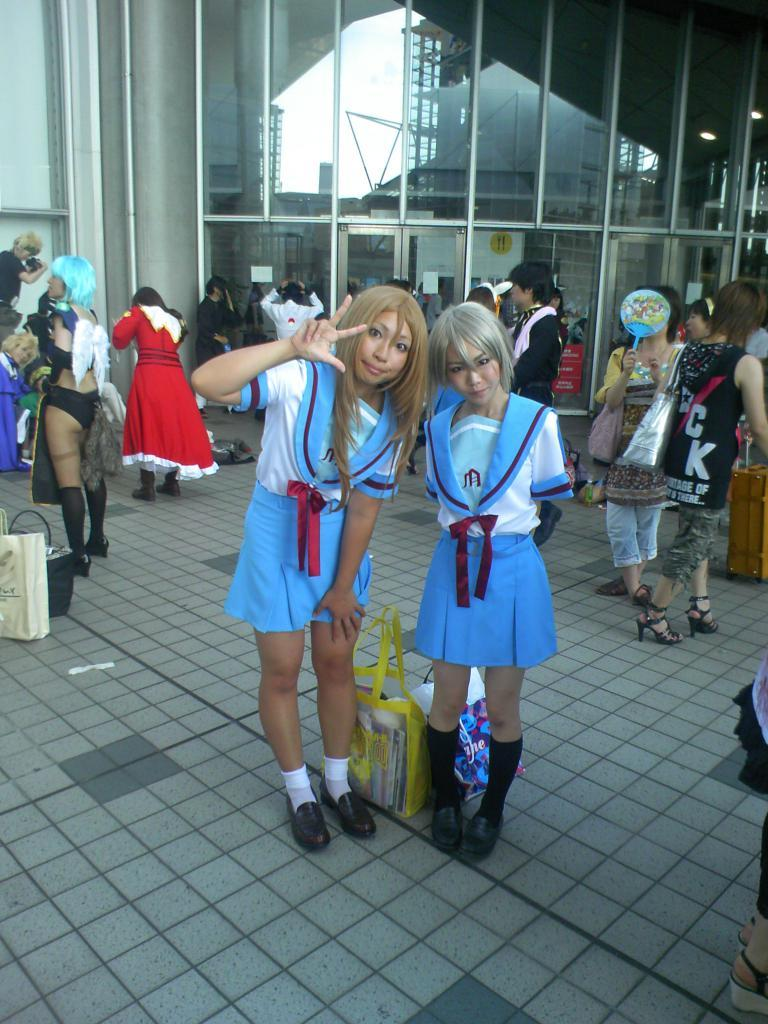How many people are present in the image? There are two persons standing in the image. What can be seen in the background of the image? There is a group of people in the background of the image. What objects are visible in the image? Bags are visible in the image. What is the reflection of in the image? There is a reflection of buildings in the image. What part of the natural environment is visible in the image? The sky is visible in the image. What type of activity is the person on the left knee doing in the image? There is no person on their knee in the image; both persons are standing. 